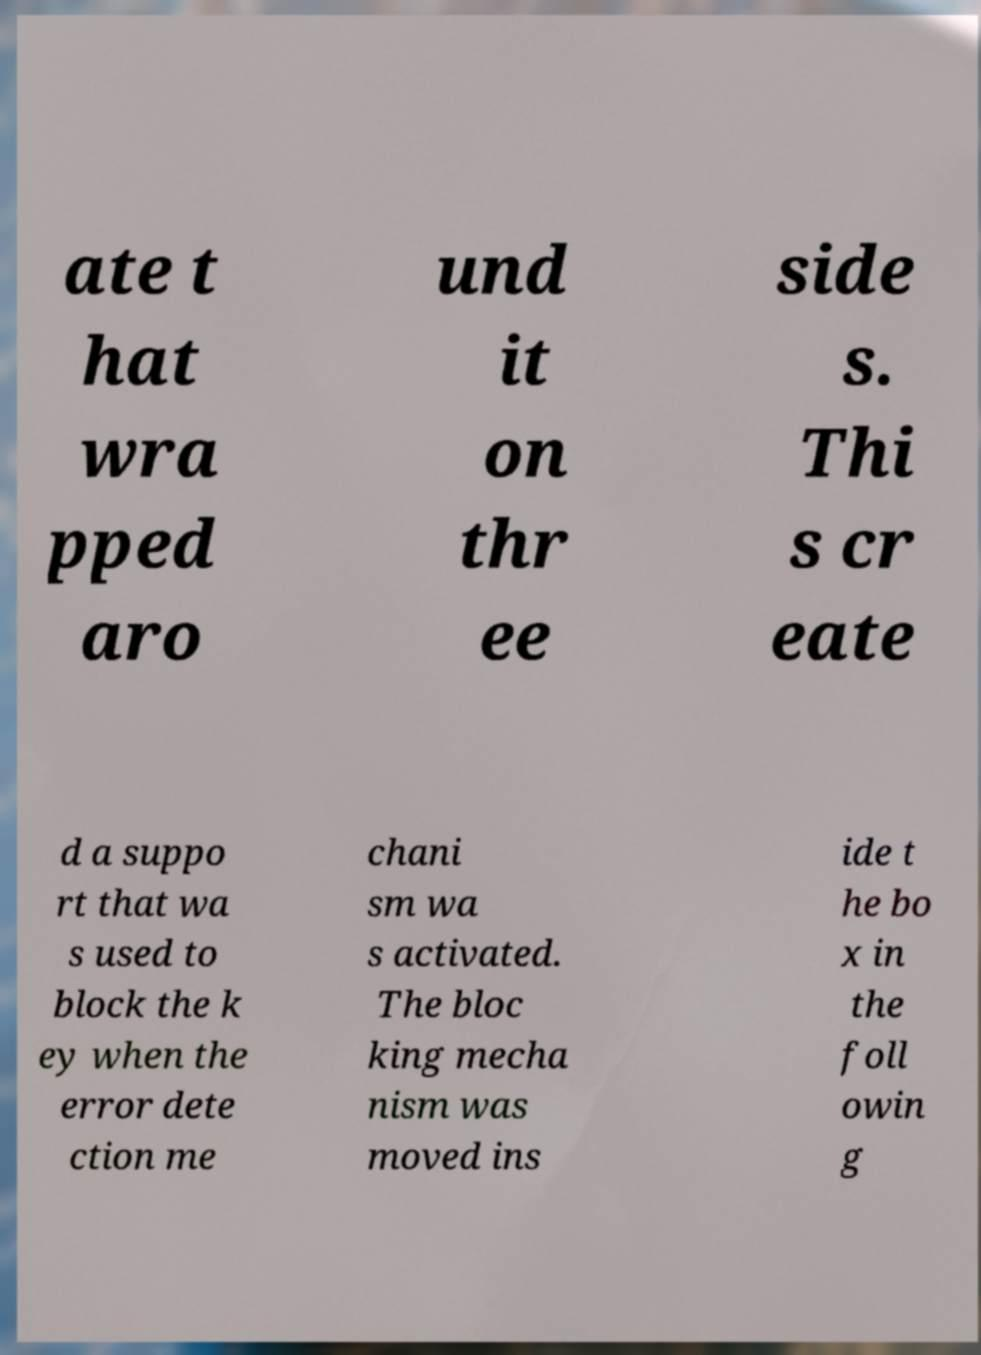For documentation purposes, I need the text within this image transcribed. Could you provide that? ate t hat wra pped aro und it on thr ee side s. Thi s cr eate d a suppo rt that wa s used to block the k ey when the error dete ction me chani sm wa s activated. The bloc king mecha nism was moved ins ide t he bo x in the foll owin g 